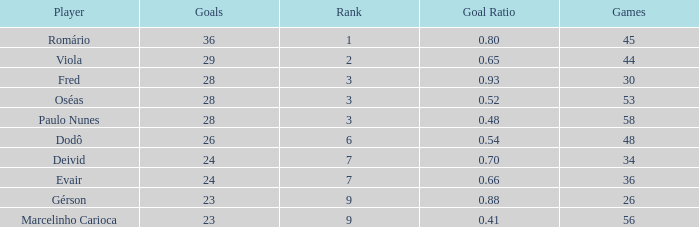How many goals have a goal ration less than 0.8 with 56 games? 1.0. 